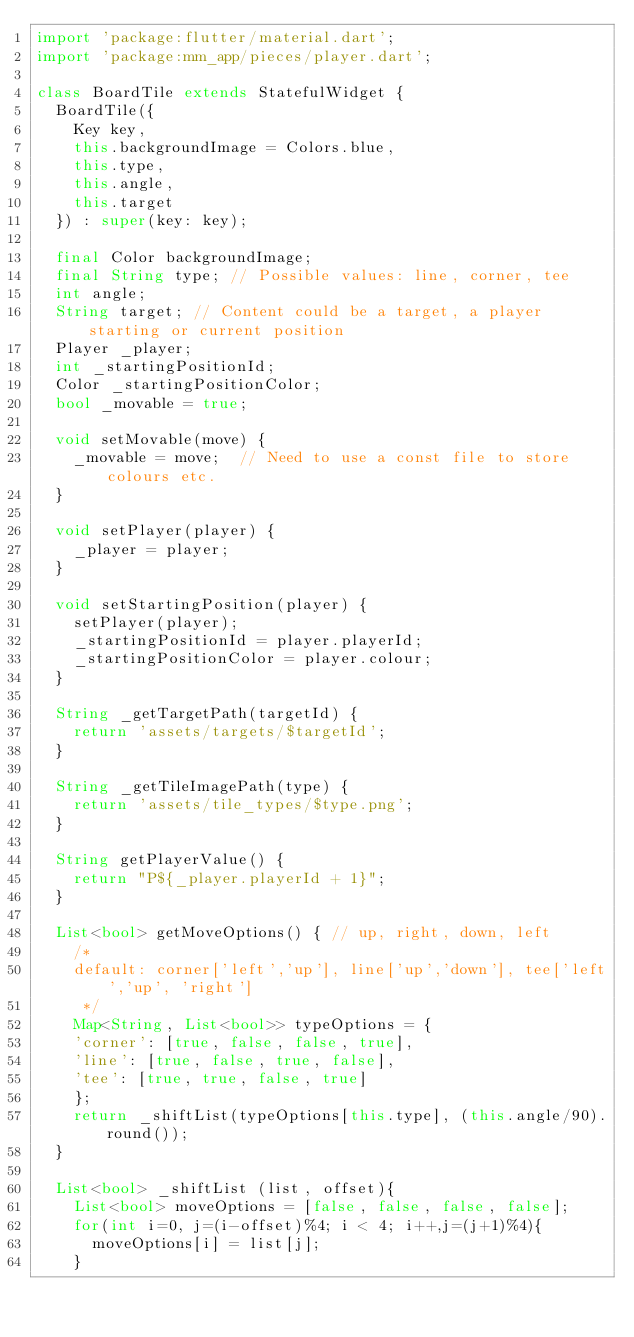<code> <loc_0><loc_0><loc_500><loc_500><_Dart_>import 'package:flutter/material.dart';
import 'package:mm_app/pieces/player.dart';

class BoardTile extends StatefulWidget {
  BoardTile({
    Key key,
    this.backgroundImage = Colors.blue,
    this.type,
    this.angle,
    this.target
  }) : super(key: key);

  final Color backgroundImage;
  final String type; // Possible values: line, corner, tee
  int angle;
  String target; // Content could be a target, a player starting or current position
  Player _player;
  int _startingPositionId;
  Color _startingPositionColor;
  bool _movable = true;

  void setMovable(move) {
    _movable = move;  // Need to use a const file to store colours etc.
  }

  void setPlayer(player) {
    _player = player;
  }

  void setStartingPosition(player) {
    setPlayer(player);
    _startingPositionId = player.playerId;
    _startingPositionColor = player.colour;
  }

  String _getTargetPath(targetId) {
    return 'assets/targets/$targetId';
  }

  String _getTileImagePath(type) {
    return 'assets/tile_types/$type.png';
  }

  String getPlayerValue() {
    return "P${_player.playerId + 1}";
  }

  List<bool> getMoveOptions() { // up, right, down, left
    /*
    default: corner['left','up'], line['up','down'], tee['left','up', 'right']
     */
    Map<String, List<bool>> typeOptions = {
    'corner': [true, false, false, true],
    'line': [true, false, true, false],
    'tee': [true, true, false, true]
    };
    return _shiftList(typeOptions[this.type], (this.angle/90).round());
  }

  List<bool> _shiftList (list, offset){
    List<bool> moveOptions = [false, false, false, false];
    for(int i=0, j=(i-offset)%4; i < 4; i++,j=(j+1)%4){
      moveOptions[i] = list[j];
    }</code> 